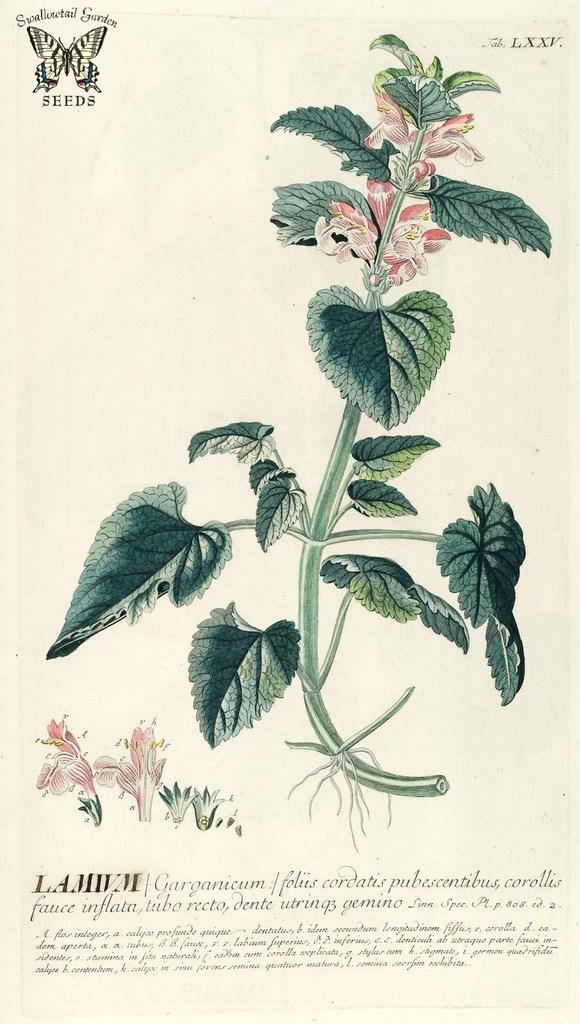What is the main object in the image? There is a poster in the image. What can be seen on the poster? There are pictures and text on the poster. How many tomatoes are being held by the fireman in the image? There is no fireman or tomatoes present in the image. What is the brother doing in the image? There is no brother present in the image. 